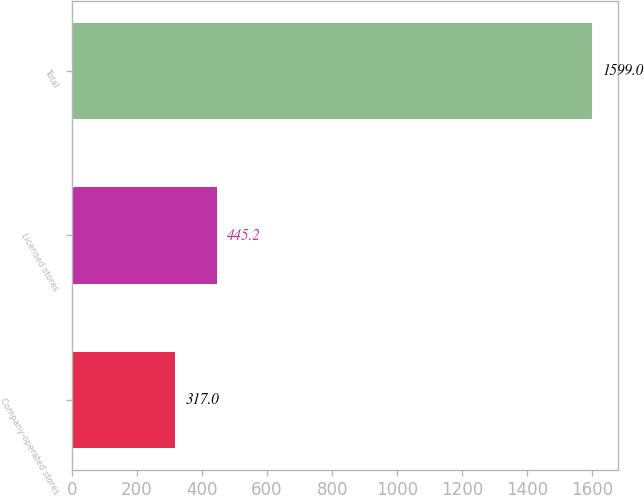Convert chart to OTSL. <chart><loc_0><loc_0><loc_500><loc_500><bar_chart><fcel>Company-operated stores<fcel>Licensed stores<fcel>Total<nl><fcel>317<fcel>445.2<fcel>1599<nl></chart> 